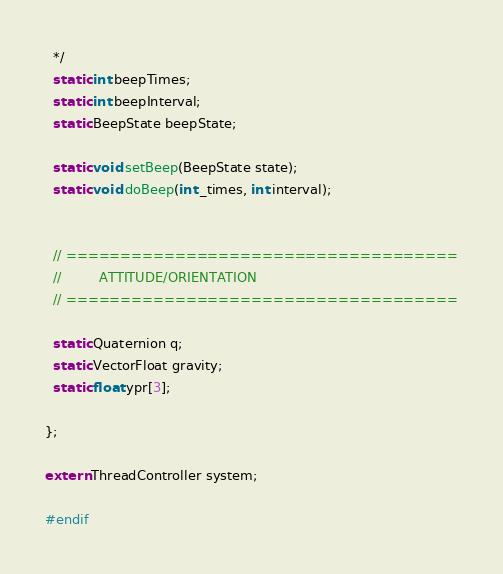<code> <loc_0><loc_0><loc_500><loc_500><_C_>  */
  static int beepTimes;
  static int beepInterval;
  static BeepState beepState;

  static void setBeep(BeepState state);
  static void doBeep(int _times, int interval);


  // ====================================
  //         ATTITUDE/ORIENTATION
  // ====================================

  static Quaternion q;
  static VectorFloat gravity;
  static float ypr[3];

};

extern ThreadController system;

#endif
</code> 